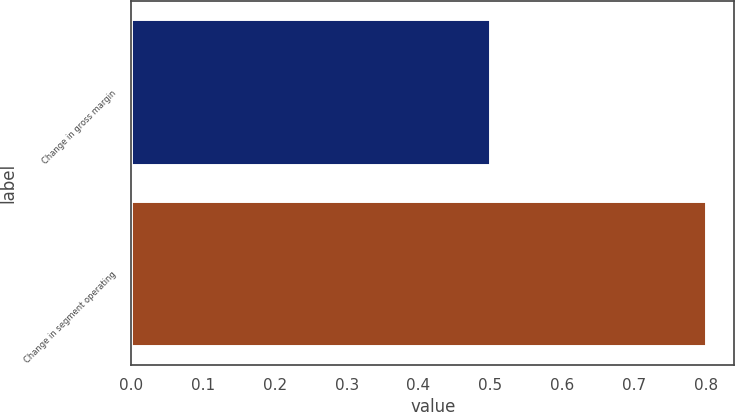Convert chart. <chart><loc_0><loc_0><loc_500><loc_500><bar_chart><fcel>Change in gross margin<fcel>Change in segment operating<nl><fcel>0.5<fcel>0.8<nl></chart> 